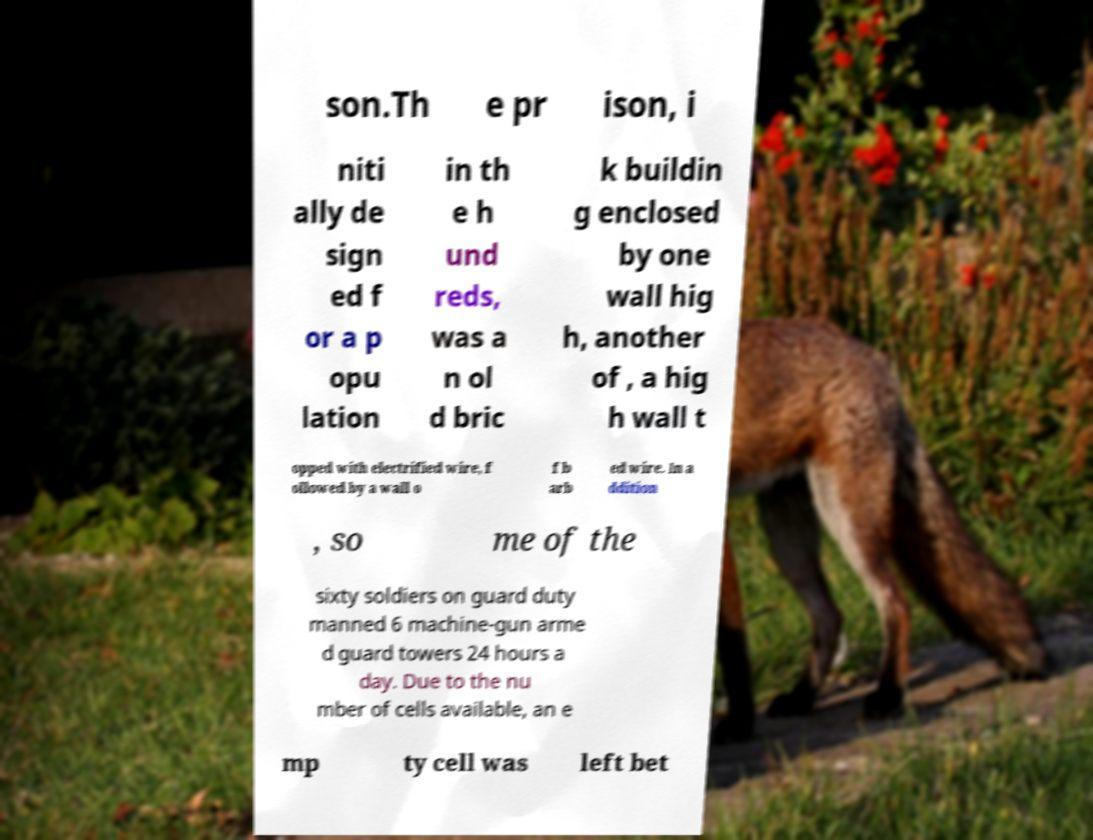I need the written content from this picture converted into text. Can you do that? son.Th e pr ison, i niti ally de sign ed f or a p opu lation in th e h und reds, was a n ol d bric k buildin g enclosed by one wall hig h, another of , a hig h wall t opped with electrified wire, f ollowed by a wall o f b arb ed wire. In a ddition , so me of the sixty soldiers on guard duty manned 6 machine-gun arme d guard towers 24 hours a day. Due to the nu mber of cells available, an e mp ty cell was left bet 